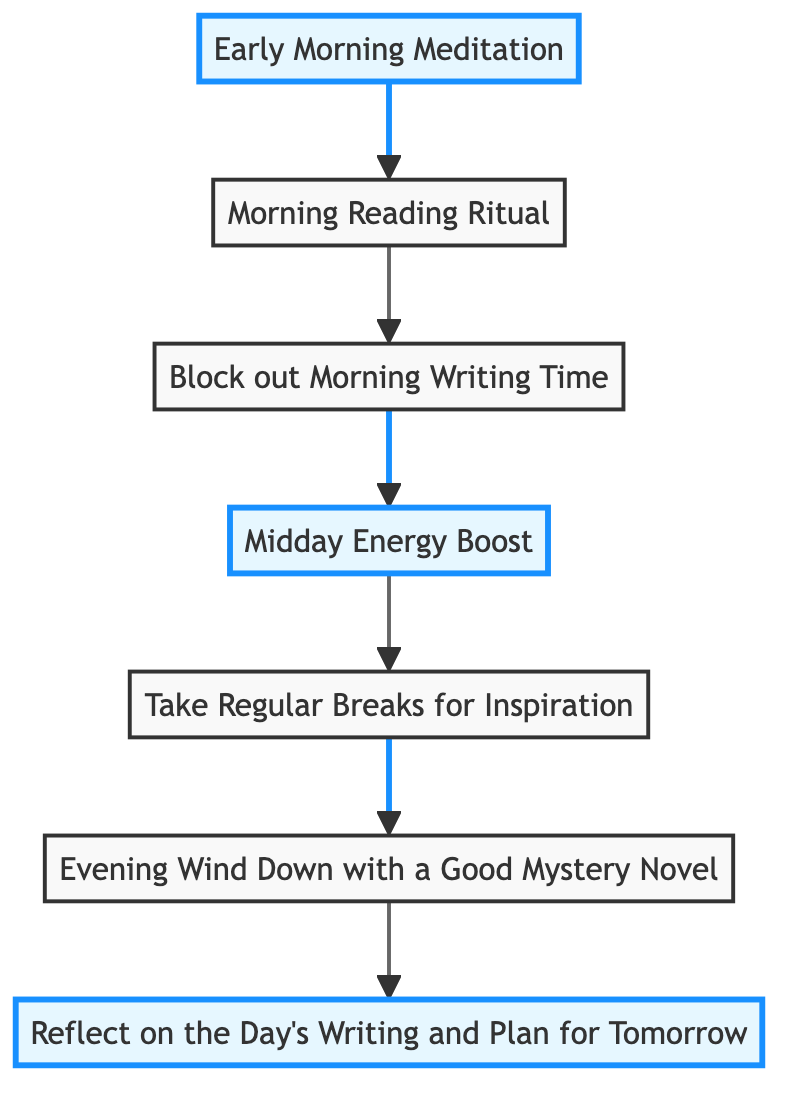What is the first activity in the diagram? The first activity in the flowchart is 'Early Morning Meditation,' as it is positioned at the bottom of the flow, indicating it is the starting point of the daily writing rituals.
Answer: Early Morning Meditation How many activities are represented in the diagram? There are a total of 7 activities represented in the flowchart, as indicated by the 7 different nodes labeled with distinct writing rituals.
Answer: 7 What is the last activity in the diagram? The last activity in the flowchart is 'Reflect on the Day's Writing and Plan for Tomorrow,' placed at the top, which indicates it is the final step in the daily writing routine.
Answer: Reflect on the Day's Writing and Plan for Tomorrow Which activity follows 'Take Regular Breaks for Inspiration'? 'Evening Wind Down with a Good Mystery Novel' follows 'Take Regular Breaks for Inspiration,' as indicated by the direction of the arrows connecting the nodes in the flowchart.
Answer: Evening Wind Down with a Good Mystery Novel How does 'Morning Reading Ritual' connect to 'Block out Morning Writing Time'? 'Morning Reading Ritual' connects to 'Block out Morning Writing Time' directly, as indicated by an arrow going upwards from the former to the latter within the flowchart indicating a sequence in the daily ritual.
Answer: Directly Which activities are highlighted in the diagram? The highlighted activities in the flowchart are 'Early Morning Meditation,' 'Midday Energy Boost,' and 'Reflect on the Day's Writing and Plan for Tomorrow,' which are emphasized with a different color to denote their importance.
Answer: Early Morning Meditation, Midday Energy Boost, Reflect on the Day's Writing and Plan for Tomorrow What is the purpose of 'Midday Energy Boost'? The purpose of 'Midday Energy Boost' is to break for lunch and fuel up with a healthy meal to enhance creativity, as described in the node's information in the flowchart.
Answer: To fuel up with a healthy meal What should be done after 'Evening Wind Down with a Good Mystery Novel'? After 'Evening Wind Down with a Good Mystery Novel,' the final activity is 'Reflect on the Day's Writing and Plan for Tomorrow,' which is the concluding part of the daily writing ritual to analyze and prepare for the next day.
Answer: Reflect on the Day's Writing and Plan for Tomorrow 